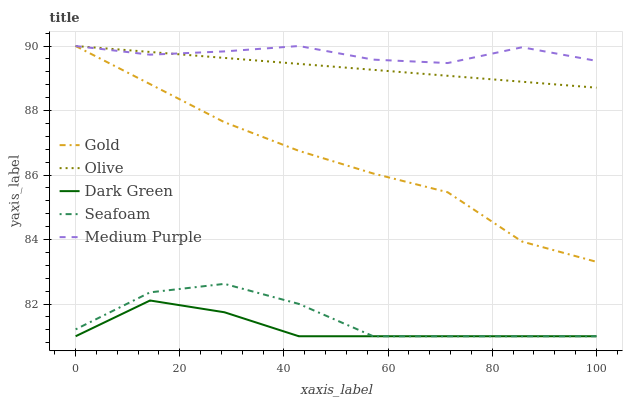Does Dark Green have the minimum area under the curve?
Answer yes or no. Yes. Does Medium Purple have the maximum area under the curve?
Answer yes or no. Yes. Does Seafoam have the minimum area under the curve?
Answer yes or no. No. Does Seafoam have the maximum area under the curve?
Answer yes or no. No. Is Olive the smoothest?
Answer yes or no. Yes. Is Seafoam the roughest?
Answer yes or no. Yes. Is Medium Purple the smoothest?
Answer yes or no. No. Is Medium Purple the roughest?
Answer yes or no. No. Does Seafoam have the lowest value?
Answer yes or no. Yes. Does Medium Purple have the lowest value?
Answer yes or no. No. Does Gold have the highest value?
Answer yes or no. Yes. Does Seafoam have the highest value?
Answer yes or no. No. Is Dark Green less than Gold?
Answer yes or no. Yes. Is Gold greater than Dark Green?
Answer yes or no. Yes. Does Gold intersect Olive?
Answer yes or no. Yes. Is Gold less than Olive?
Answer yes or no. No. Is Gold greater than Olive?
Answer yes or no. No. Does Dark Green intersect Gold?
Answer yes or no. No. 